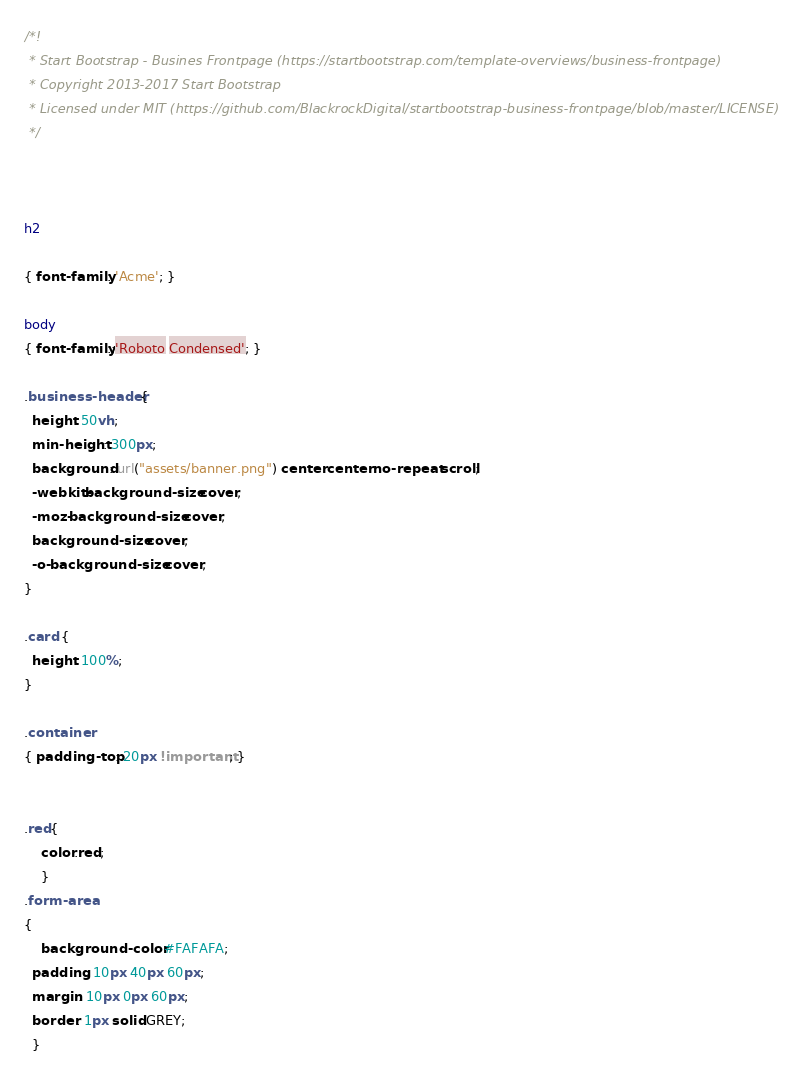Convert code to text. <code><loc_0><loc_0><loc_500><loc_500><_CSS_>/*!
 * Start Bootstrap - Busines Frontpage (https://startbootstrap.com/template-overviews/business-frontpage)
 * Copyright 2013-2017 Start Bootstrap
 * Licensed under MIT (https://github.com/BlackrockDigital/startbootstrap-business-frontpage/blob/master/LICENSE)
 */



h2

{ font-family: 'Acme'; }

body 
{ font-family:;'Roboto Condensed'; }

.business-header {
  height: 50vh;
  min-height: 300px;
  background: url("assets/banner.png") center center no-repeat scroll;
  -webkit-background-size: cover;
  -moz-background-size: cover;
  background-size: cover;
  -o-background-size: cover;
}

.card {
  height: 100%;
}

.container
{ padding-top: 20px !important; }


.red{
    color:red;
    }
.form-area
{
    background-color: #FAFAFA;
  padding: 10px 40px 60px;
  margin: 10px 0px 60px;
  border: 1px solid GREY;
  }</code> 